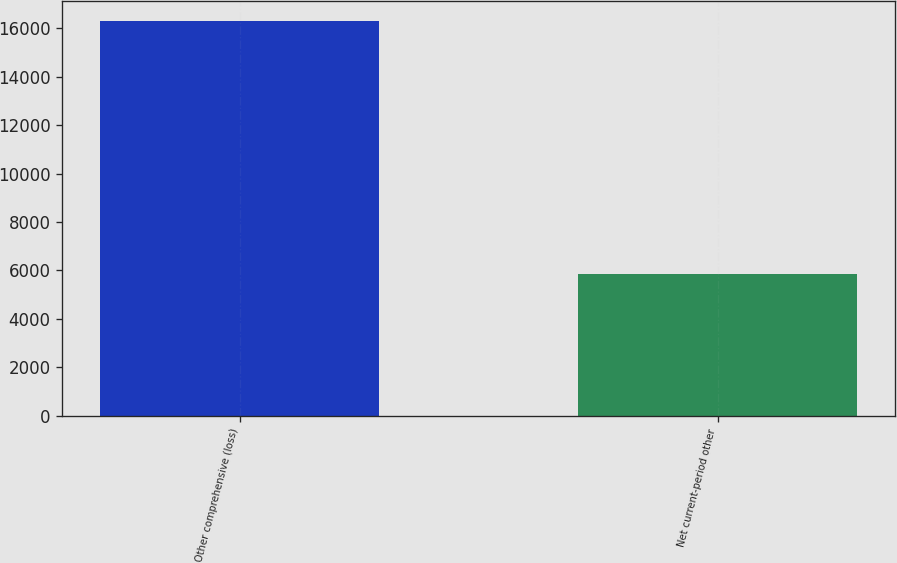Convert chart to OTSL. <chart><loc_0><loc_0><loc_500><loc_500><bar_chart><fcel>Other comprehensive (loss)<fcel>Net current-period other<nl><fcel>16300<fcel>5870<nl></chart> 